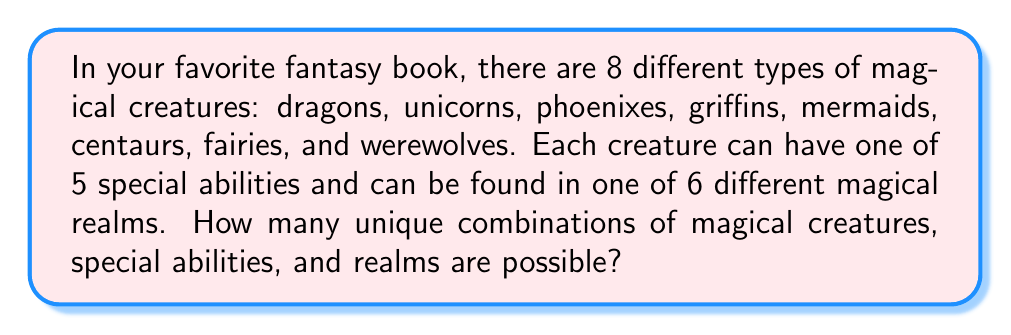Solve this math problem. Let's approach this step-by-step:

1) We have three independent factors to consider:
   - Type of magical creature (8 options)
   - Special ability (5 options)
   - Magical realm (6 options)

2) For each magical creature, we can choose any of the 5 special abilities and any of the 6 realms.

3) This is a perfect scenario for using the multiplication principle. The multiplication principle states that if we have $m$ ways of doing something, $n$ ways of doing another thing, and $p$ ways of doing a third thing, then there are $m \times n \times p$ ways to do all three things.

4) In this case:
   - There are 8 ways to choose the magical creature
   - For each creature, there are 5 ways to choose the special ability
   - For each creature-ability combination, there are 6 ways to choose the realm

5) Therefore, the total number of unique combinations is:

   $$8 \times 5 \times 6 = 240$$

This means there are 240 unique combinations of magical creatures, special abilities, and realms possible in this fantasy world.
Answer: 240 